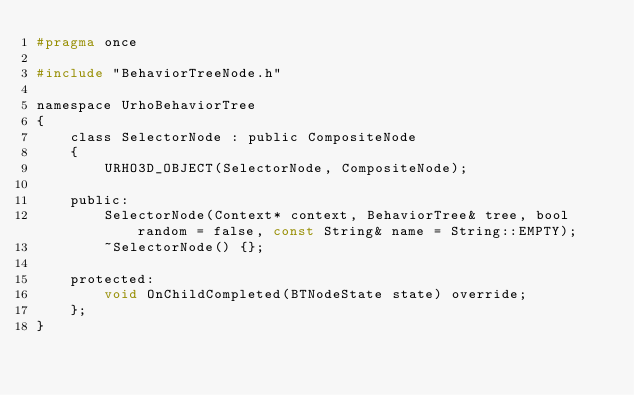Convert code to text. <code><loc_0><loc_0><loc_500><loc_500><_C_>#pragma once

#include "BehaviorTreeNode.h"

namespace UrhoBehaviorTree
{
    class SelectorNode : public CompositeNode
    {
        URHO3D_OBJECT(SelectorNode, CompositeNode);

    public:
        SelectorNode(Context* context, BehaviorTree& tree, bool random = false, const String& name = String::EMPTY);
        ~SelectorNode() {};

    protected:
        void OnChildCompleted(BTNodeState state) override;
    };
}
</code> 